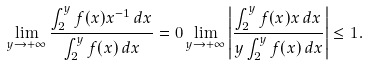<formula> <loc_0><loc_0><loc_500><loc_500>\lim _ { y \rightarrow + \infty } \frac { \int _ { 2 } ^ { y } f ( x ) x ^ { - 1 } \, d x } { \int _ { 2 } ^ { y } f ( x ) \, d x } = 0 \lim _ { y \rightarrow + \infty } \left | \frac { \int _ { 2 } ^ { y } f ( x ) x \, d x } { y \int _ { 2 } ^ { y } f ( x ) \, d x } \right | \leq 1 .</formula> 